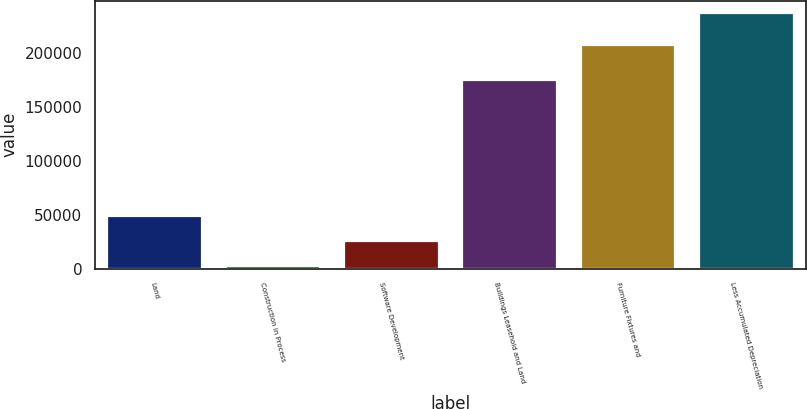Convert chart to OTSL. <chart><loc_0><loc_0><loc_500><loc_500><bar_chart><fcel>Land<fcel>Construction in Process<fcel>Software Development<fcel>Buildings Leasehold and Land<fcel>Furniture Fixtures and<fcel>Less Accumulated Depreciation<nl><fcel>49026.6<fcel>2111<fcel>25568.8<fcel>174680<fcel>207437<fcel>236689<nl></chart> 